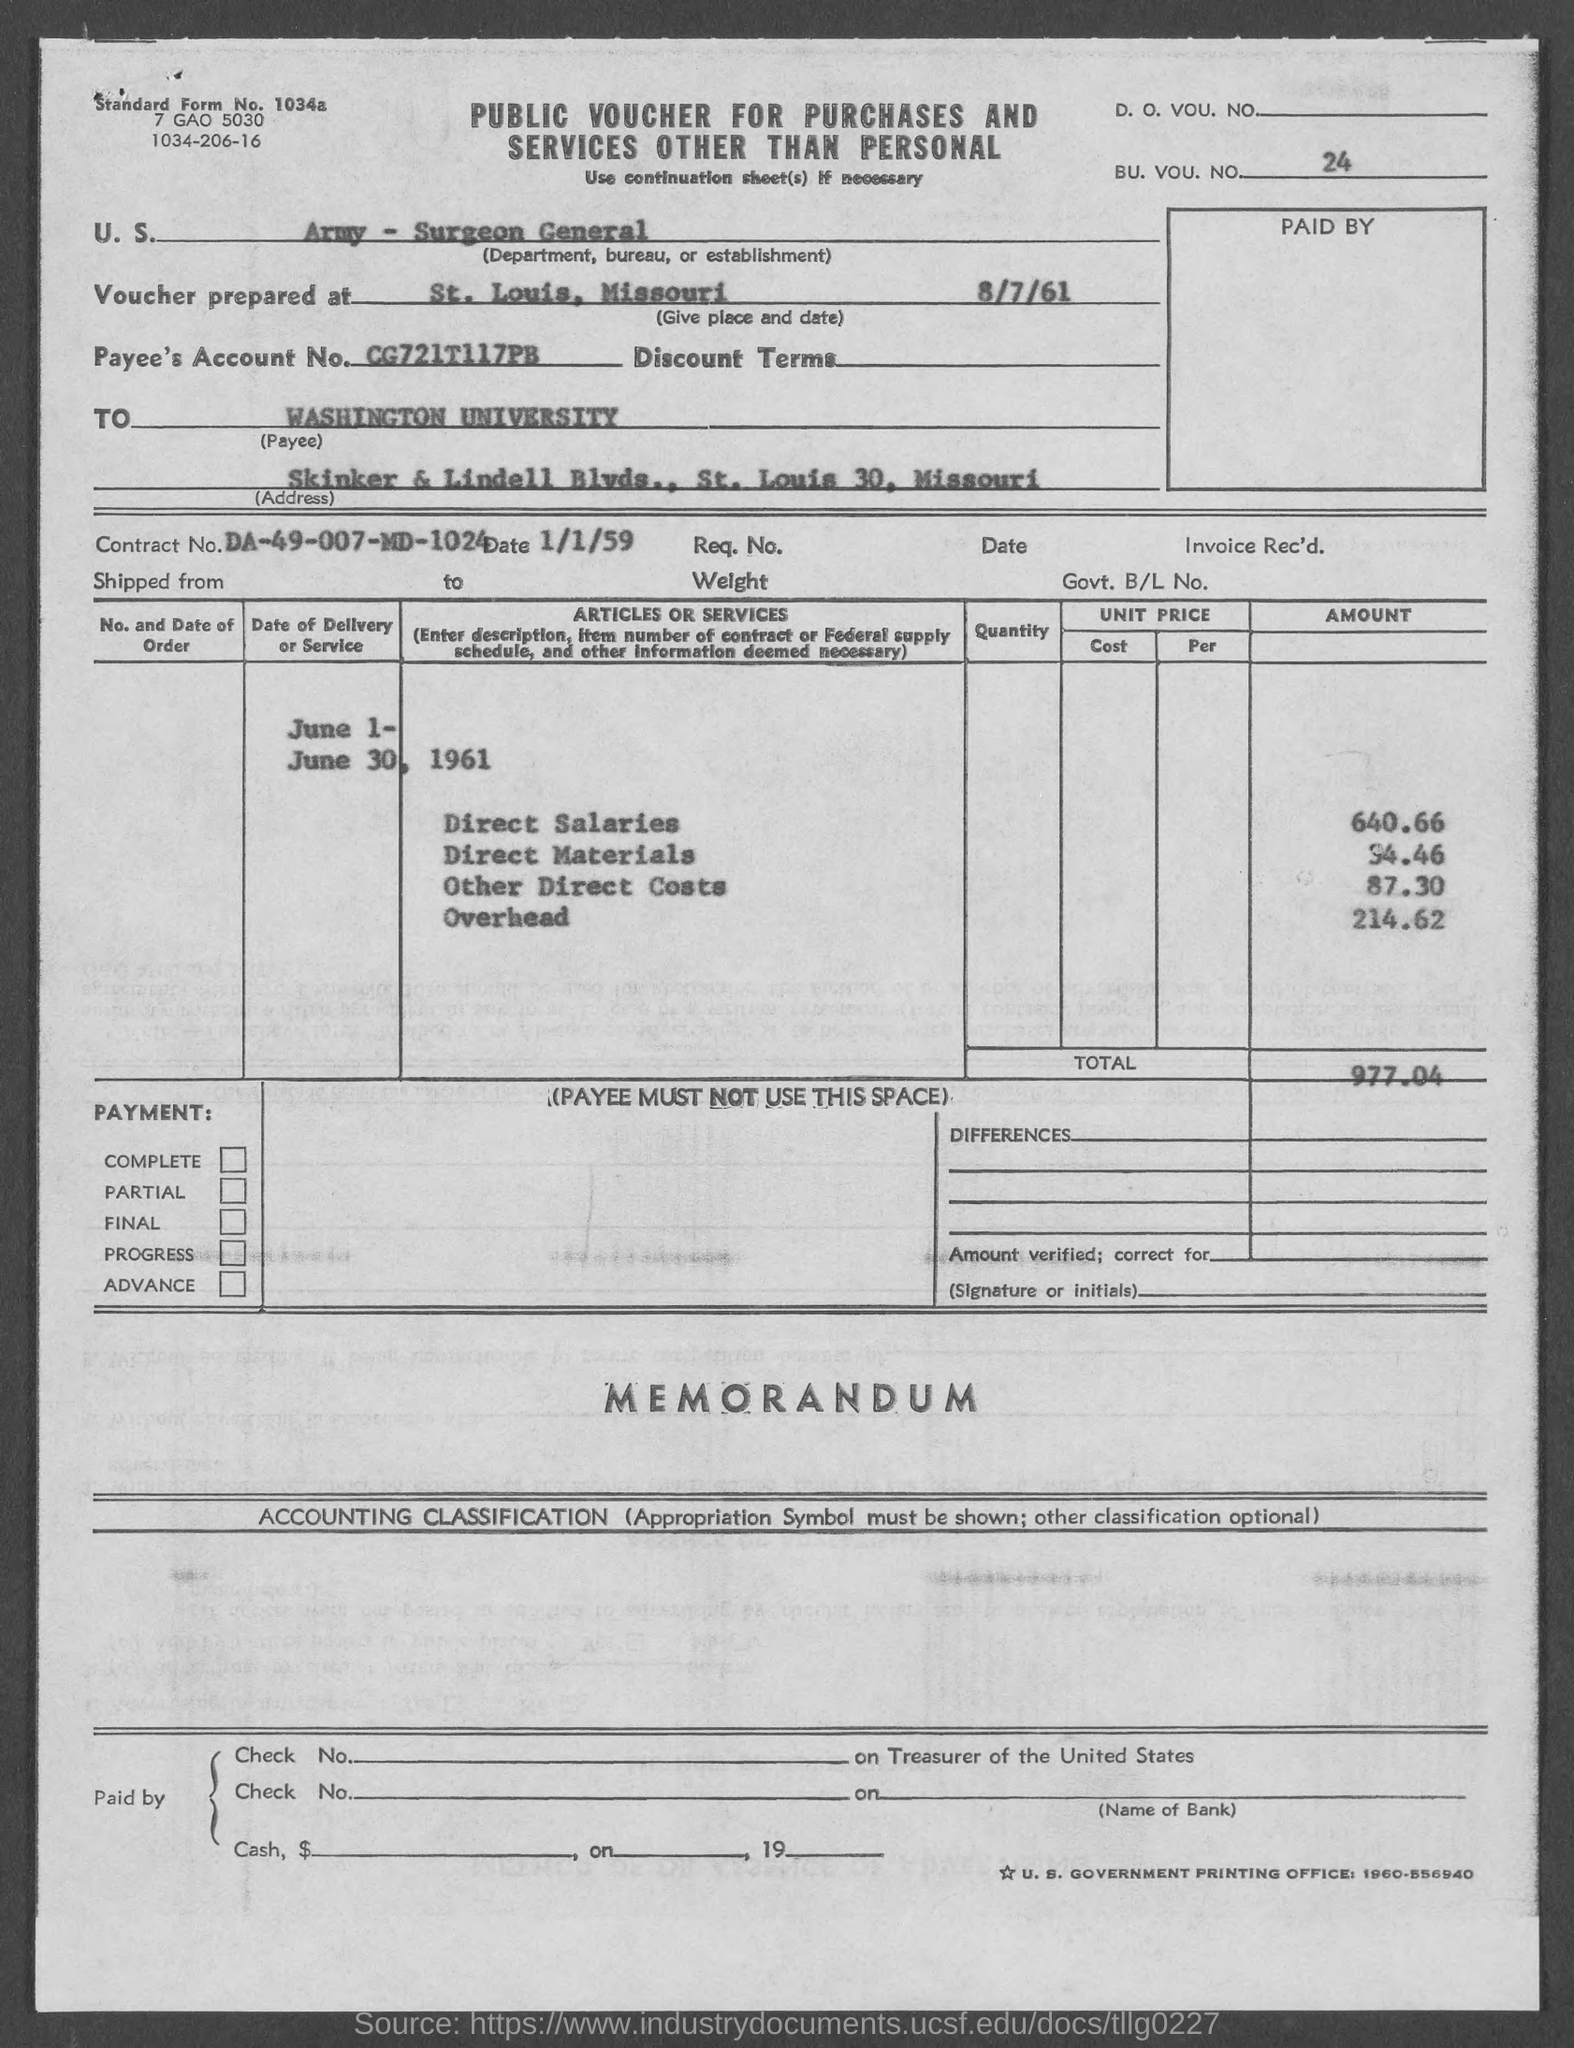Mention a couple of crucial points in this snapshot. The date of the contract mentioned in the voucher is January 1, 1959. The total voucher amount mentioned in the document is 977.04. The BU. VOU. NO. mentioned in the voucher is 24.. The Contract No. given in the voucher is DA-49-007-MD-1024. The voucher was prepared on August 7th, 1961, in St. Louis, Missouri. 